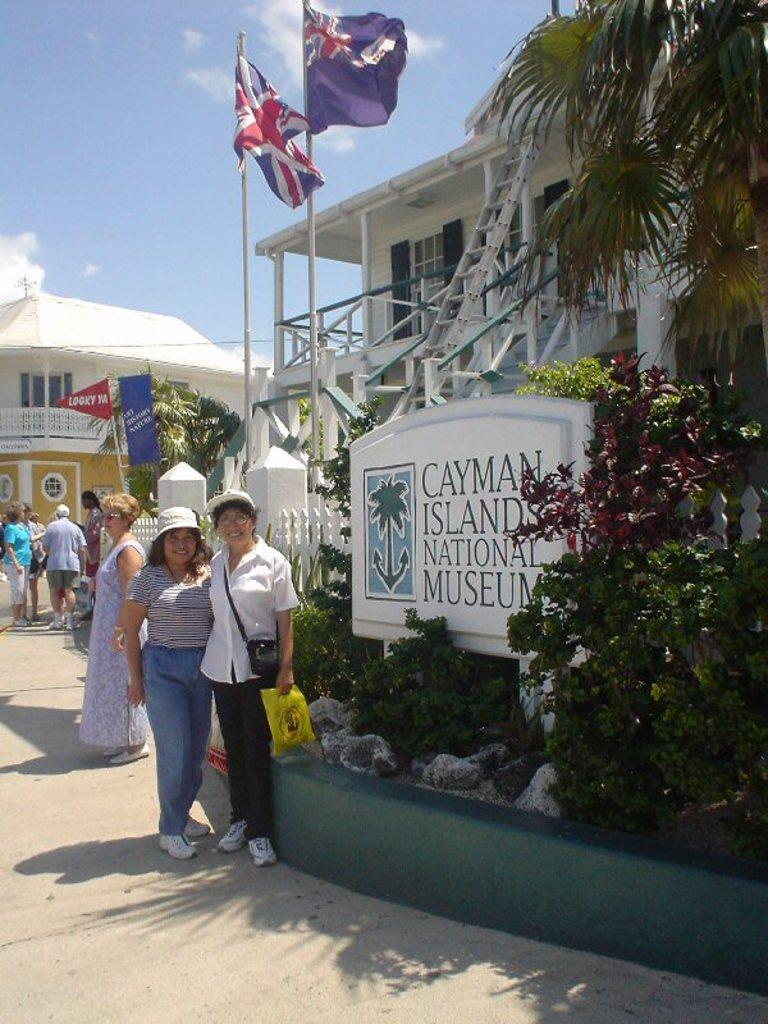What can be seen in the image involving human presence? There are people standing in the image. What type of natural elements are present in the image? There are plants in the image. What type of man-made structures can be seen in the image? There are buildings in the image. What is the color of the sky in the image? The sky is blue and visible at the top of the image. What type of gold jewelry can be seen on the people in the image? There is no gold jewelry visible on the people in the image. Can you describe the bird that is flying in the sky in the image? There is no bird present in the image; the sky is blue and visible, but no bird is depicted. 